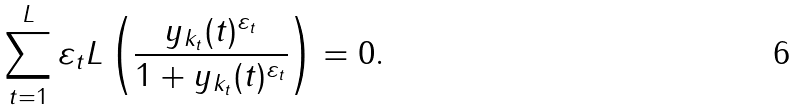<formula> <loc_0><loc_0><loc_500><loc_500>\sum _ { t = 1 } ^ { L } \varepsilon _ { t } L \left ( \frac { y _ { k _ { t } } ( t ) ^ { \varepsilon _ { t } } } { 1 + y _ { k _ { t } } ( t ) ^ { \varepsilon _ { t } } } \right ) = 0 .</formula> 